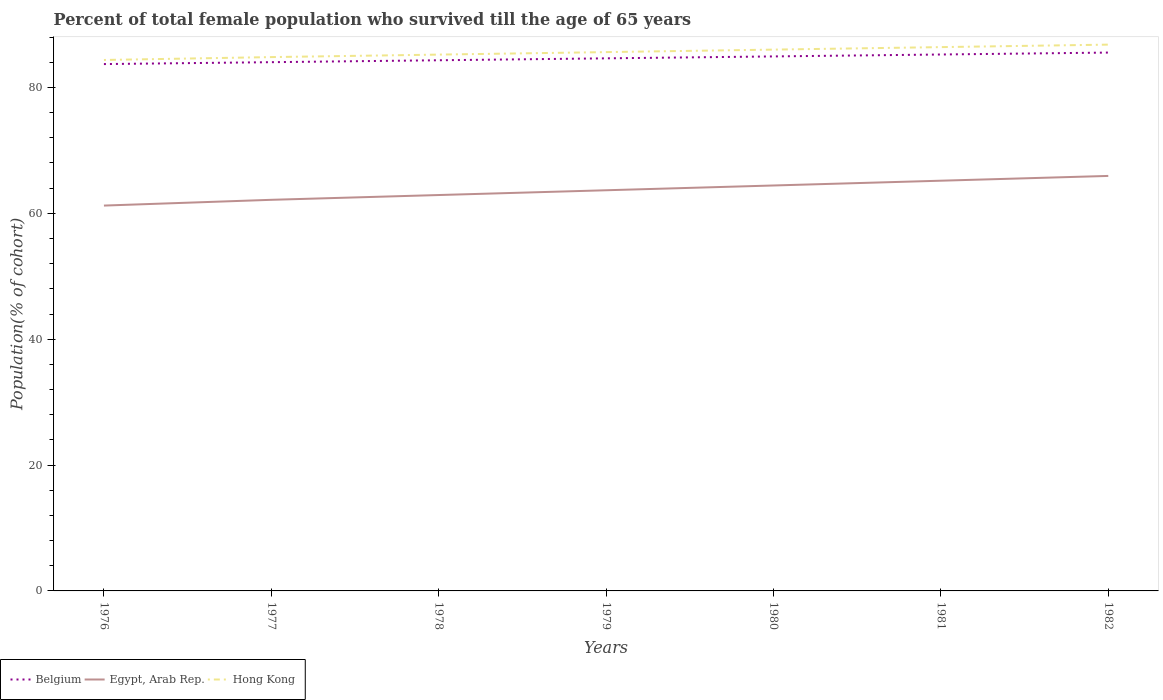Across all years, what is the maximum percentage of total female population who survived till the age of 65 years in Egypt, Arab Rep.?
Offer a very short reply. 61.23. In which year was the percentage of total female population who survived till the age of 65 years in Hong Kong maximum?
Provide a succinct answer. 1976. What is the total percentage of total female population who survived till the age of 65 years in Egypt, Arab Rep. in the graph?
Make the answer very short. -1.52. What is the difference between the highest and the second highest percentage of total female population who survived till the age of 65 years in Hong Kong?
Keep it short and to the point. 2.44. What is the difference between the highest and the lowest percentage of total female population who survived till the age of 65 years in Belgium?
Provide a short and direct response. 3. How many years are there in the graph?
Your answer should be very brief. 7. What is the difference between two consecutive major ticks on the Y-axis?
Provide a short and direct response. 20. Are the values on the major ticks of Y-axis written in scientific E-notation?
Your response must be concise. No. How are the legend labels stacked?
Ensure brevity in your answer.  Horizontal. What is the title of the graph?
Give a very brief answer. Percent of total female population who survived till the age of 65 years. Does "China" appear as one of the legend labels in the graph?
Ensure brevity in your answer.  No. What is the label or title of the Y-axis?
Your answer should be very brief. Population(% of cohort). What is the Population(% of cohort) in Belgium in 1976?
Your answer should be compact. 83.72. What is the Population(% of cohort) of Egypt, Arab Rep. in 1976?
Make the answer very short. 61.23. What is the Population(% of cohort) of Hong Kong in 1976?
Offer a terse response. 84.37. What is the Population(% of cohort) in Belgium in 1977?
Keep it short and to the point. 84.02. What is the Population(% of cohort) in Egypt, Arab Rep. in 1977?
Your response must be concise. 62.15. What is the Population(% of cohort) in Hong Kong in 1977?
Keep it short and to the point. 84.82. What is the Population(% of cohort) of Belgium in 1978?
Your answer should be compact. 84.32. What is the Population(% of cohort) of Egypt, Arab Rep. in 1978?
Your answer should be very brief. 62.91. What is the Population(% of cohort) of Hong Kong in 1978?
Your answer should be compact. 85.22. What is the Population(% of cohort) of Belgium in 1979?
Provide a short and direct response. 84.63. What is the Population(% of cohort) in Egypt, Arab Rep. in 1979?
Provide a short and direct response. 63.67. What is the Population(% of cohort) in Hong Kong in 1979?
Keep it short and to the point. 85.62. What is the Population(% of cohort) in Belgium in 1980?
Provide a succinct answer. 84.93. What is the Population(% of cohort) in Egypt, Arab Rep. in 1980?
Your answer should be very brief. 64.42. What is the Population(% of cohort) of Hong Kong in 1980?
Your answer should be compact. 86.01. What is the Population(% of cohort) in Belgium in 1981?
Give a very brief answer. 85.24. What is the Population(% of cohort) of Egypt, Arab Rep. in 1981?
Provide a short and direct response. 65.18. What is the Population(% of cohort) in Hong Kong in 1981?
Your answer should be very brief. 86.41. What is the Population(% of cohort) of Belgium in 1982?
Make the answer very short. 85.54. What is the Population(% of cohort) in Egypt, Arab Rep. in 1982?
Ensure brevity in your answer.  65.94. What is the Population(% of cohort) in Hong Kong in 1982?
Keep it short and to the point. 86.81. Across all years, what is the maximum Population(% of cohort) in Belgium?
Offer a very short reply. 85.54. Across all years, what is the maximum Population(% of cohort) of Egypt, Arab Rep.?
Your answer should be very brief. 65.94. Across all years, what is the maximum Population(% of cohort) in Hong Kong?
Provide a short and direct response. 86.81. Across all years, what is the minimum Population(% of cohort) of Belgium?
Ensure brevity in your answer.  83.72. Across all years, what is the minimum Population(% of cohort) in Egypt, Arab Rep.?
Provide a succinct answer. 61.23. Across all years, what is the minimum Population(% of cohort) in Hong Kong?
Offer a terse response. 84.37. What is the total Population(% of cohort) in Belgium in the graph?
Provide a succinct answer. 592.4. What is the total Population(% of cohort) in Egypt, Arab Rep. in the graph?
Ensure brevity in your answer.  445.5. What is the total Population(% of cohort) of Hong Kong in the graph?
Provide a short and direct response. 599.26. What is the difference between the Population(% of cohort) in Belgium in 1976 and that in 1977?
Ensure brevity in your answer.  -0.3. What is the difference between the Population(% of cohort) in Egypt, Arab Rep. in 1976 and that in 1977?
Give a very brief answer. -0.92. What is the difference between the Population(% of cohort) of Hong Kong in 1976 and that in 1977?
Your answer should be compact. -0.46. What is the difference between the Population(% of cohort) in Belgium in 1976 and that in 1978?
Provide a succinct answer. -0.61. What is the difference between the Population(% of cohort) of Egypt, Arab Rep. in 1976 and that in 1978?
Your answer should be compact. -1.67. What is the difference between the Population(% of cohort) of Hong Kong in 1976 and that in 1978?
Your response must be concise. -0.85. What is the difference between the Population(% of cohort) of Belgium in 1976 and that in 1979?
Offer a very short reply. -0.91. What is the difference between the Population(% of cohort) of Egypt, Arab Rep. in 1976 and that in 1979?
Offer a very short reply. -2.43. What is the difference between the Population(% of cohort) of Hong Kong in 1976 and that in 1979?
Your answer should be very brief. -1.25. What is the difference between the Population(% of cohort) of Belgium in 1976 and that in 1980?
Offer a terse response. -1.22. What is the difference between the Population(% of cohort) of Egypt, Arab Rep. in 1976 and that in 1980?
Keep it short and to the point. -3.19. What is the difference between the Population(% of cohort) of Hong Kong in 1976 and that in 1980?
Offer a terse response. -1.65. What is the difference between the Population(% of cohort) of Belgium in 1976 and that in 1981?
Offer a terse response. -1.52. What is the difference between the Population(% of cohort) in Egypt, Arab Rep. in 1976 and that in 1981?
Keep it short and to the point. -3.95. What is the difference between the Population(% of cohort) in Hong Kong in 1976 and that in 1981?
Give a very brief answer. -2.04. What is the difference between the Population(% of cohort) of Belgium in 1976 and that in 1982?
Give a very brief answer. -1.83. What is the difference between the Population(% of cohort) of Egypt, Arab Rep. in 1976 and that in 1982?
Give a very brief answer. -4.71. What is the difference between the Population(% of cohort) in Hong Kong in 1976 and that in 1982?
Your answer should be compact. -2.44. What is the difference between the Population(% of cohort) of Belgium in 1977 and that in 1978?
Provide a short and direct response. -0.31. What is the difference between the Population(% of cohort) in Egypt, Arab Rep. in 1977 and that in 1978?
Provide a short and direct response. -0.76. What is the difference between the Population(% of cohort) of Hong Kong in 1977 and that in 1978?
Your answer should be very brief. -0.4. What is the difference between the Population(% of cohort) in Belgium in 1977 and that in 1979?
Ensure brevity in your answer.  -0.61. What is the difference between the Population(% of cohort) in Egypt, Arab Rep. in 1977 and that in 1979?
Make the answer very short. -1.52. What is the difference between the Population(% of cohort) in Hong Kong in 1977 and that in 1979?
Offer a very short reply. -0.79. What is the difference between the Population(% of cohort) of Belgium in 1977 and that in 1980?
Provide a short and direct response. -0.92. What is the difference between the Population(% of cohort) in Egypt, Arab Rep. in 1977 and that in 1980?
Offer a very short reply. -2.28. What is the difference between the Population(% of cohort) in Hong Kong in 1977 and that in 1980?
Your answer should be very brief. -1.19. What is the difference between the Population(% of cohort) of Belgium in 1977 and that in 1981?
Ensure brevity in your answer.  -1.22. What is the difference between the Population(% of cohort) in Egypt, Arab Rep. in 1977 and that in 1981?
Provide a succinct answer. -3.04. What is the difference between the Population(% of cohort) of Hong Kong in 1977 and that in 1981?
Offer a terse response. -1.59. What is the difference between the Population(% of cohort) in Belgium in 1977 and that in 1982?
Offer a very short reply. -1.53. What is the difference between the Population(% of cohort) of Egypt, Arab Rep. in 1977 and that in 1982?
Keep it short and to the point. -3.8. What is the difference between the Population(% of cohort) in Hong Kong in 1977 and that in 1982?
Ensure brevity in your answer.  -1.98. What is the difference between the Population(% of cohort) in Belgium in 1978 and that in 1979?
Provide a succinct answer. -0.31. What is the difference between the Population(% of cohort) of Egypt, Arab Rep. in 1978 and that in 1979?
Provide a succinct answer. -0.76. What is the difference between the Population(% of cohort) in Hong Kong in 1978 and that in 1979?
Provide a succinct answer. -0.4. What is the difference between the Population(% of cohort) of Belgium in 1978 and that in 1980?
Keep it short and to the point. -0.61. What is the difference between the Population(% of cohort) of Egypt, Arab Rep. in 1978 and that in 1980?
Provide a short and direct response. -1.52. What is the difference between the Population(% of cohort) in Hong Kong in 1978 and that in 1980?
Provide a short and direct response. -0.79. What is the difference between the Population(% of cohort) of Belgium in 1978 and that in 1981?
Your answer should be very brief. -0.92. What is the difference between the Population(% of cohort) in Egypt, Arab Rep. in 1978 and that in 1981?
Offer a terse response. -2.28. What is the difference between the Population(% of cohort) of Hong Kong in 1978 and that in 1981?
Offer a very short reply. -1.19. What is the difference between the Population(% of cohort) in Belgium in 1978 and that in 1982?
Provide a succinct answer. -1.22. What is the difference between the Population(% of cohort) of Egypt, Arab Rep. in 1978 and that in 1982?
Make the answer very short. -3.04. What is the difference between the Population(% of cohort) of Hong Kong in 1978 and that in 1982?
Make the answer very short. -1.59. What is the difference between the Population(% of cohort) in Belgium in 1979 and that in 1980?
Provide a succinct answer. -0.31. What is the difference between the Population(% of cohort) in Egypt, Arab Rep. in 1979 and that in 1980?
Provide a short and direct response. -0.76. What is the difference between the Population(% of cohort) of Hong Kong in 1979 and that in 1980?
Your response must be concise. -0.4. What is the difference between the Population(% of cohort) in Belgium in 1979 and that in 1981?
Keep it short and to the point. -0.61. What is the difference between the Population(% of cohort) in Egypt, Arab Rep. in 1979 and that in 1981?
Offer a terse response. -1.52. What is the difference between the Population(% of cohort) in Hong Kong in 1979 and that in 1981?
Provide a succinct answer. -0.79. What is the difference between the Population(% of cohort) in Belgium in 1979 and that in 1982?
Your answer should be very brief. -0.92. What is the difference between the Population(% of cohort) in Egypt, Arab Rep. in 1979 and that in 1982?
Provide a succinct answer. -2.28. What is the difference between the Population(% of cohort) of Hong Kong in 1979 and that in 1982?
Ensure brevity in your answer.  -1.19. What is the difference between the Population(% of cohort) of Belgium in 1980 and that in 1981?
Your response must be concise. -0.31. What is the difference between the Population(% of cohort) in Egypt, Arab Rep. in 1980 and that in 1981?
Provide a succinct answer. -0.76. What is the difference between the Population(% of cohort) in Hong Kong in 1980 and that in 1981?
Provide a short and direct response. -0.4. What is the difference between the Population(% of cohort) in Belgium in 1980 and that in 1982?
Provide a short and direct response. -0.61. What is the difference between the Population(% of cohort) of Egypt, Arab Rep. in 1980 and that in 1982?
Make the answer very short. -1.52. What is the difference between the Population(% of cohort) in Hong Kong in 1980 and that in 1982?
Offer a terse response. -0.79. What is the difference between the Population(% of cohort) of Belgium in 1981 and that in 1982?
Offer a terse response. -0.31. What is the difference between the Population(% of cohort) of Egypt, Arab Rep. in 1981 and that in 1982?
Your answer should be compact. -0.76. What is the difference between the Population(% of cohort) in Hong Kong in 1981 and that in 1982?
Your answer should be very brief. -0.4. What is the difference between the Population(% of cohort) in Belgium in 1976 and the Population(% of cohort) in Egypt, Arab Rep. in 1977?
Offer a very short reply. 21.57. What is the difference between the Population(% of cohort) in Belgium in 1976 and the Population(% of cohort) in Hong Kong in 1977?
Offer a terse response. -1.11. What is the difference between the Population(% of cohort) in Egypt, Arab Rep. in 1976 and the Population(% of cohort) in Hong Kong in 1977?
Ensure brevity in your answer.  -23.59. What is the difference between the Population(% of cohort) in Belgium in 1976 and the Population(% of cohort) in Egypt, Arab Rep. in 1978?
Provide a short and direct response. 20.81. What is the difference between the Population(% of cohort) of Belgium in 1976 and the Population(% of cohort) of Hong Kong in 1978?
Your answer should be very brief. -1.5. What is the difference between the Population(% of cohort) in Egypt, Arab Rep. in 1976 and the Population(% of cohort) in Hong Kong in 1978?
Provide a succinct answer. -23.99. What is the difference between the Population(% of cohort) in Belgium in 1976 and the Population(% of cohort) in Egypt, Arab Rep. in 1979?
Give a very brief answer. 20.05. What is the difference between the Population(% of cohort) in Belgium in 1976 and the Population(% of cohort) in Hong Kong in 1979?
Make the answer very short. -1.9. What is the difference between the Population(% of cohort) of Egypt, Arab Rep. in 1976 and the Population(% of cohort) of Hong Kong in 1979?
Offer a terse response. -24.39. What is the difference between the Population(% of cohort) of Belgium in 1976 and the Population(% of cohort) of Egypt, Arab Rep. in 1980?
Ensure brevity in your answer.  19.29. What is the difference between the Population(% of cohort) in Belgium in 1976 and the Population(% of cohort) in Hong Kong in 1980?
Ensure brevity in your answer.  -2.3. What is the difference between the Population(% of cohort) of Egypt, Arab Rep. in 1976 and the Population(% of cohort) of Hong Kong in 1980?
Your answer should be compact. -24.78. What is the difference between the Population(% of cohort) in Belgium in 1976 and the Population(% of cohort) in Egypt, Arab Rep. in 1981?
Make the answer very short. 18.53. What is the difference between the Population(% of cohort) of Belgium in 1976 and the Population(% of cohort) of Hong Kong in 1981?
Your response must be concise. -2.69. What is the difference between the Population(% of cohort) of Egypt, Arab Rep. in 1976 and the Population(% of cohort) of Hong Kong in 1981?
Your answer should be compact. -25.18. What is the difference between the Population(% of cohort) in Belgium in 1976 and the Population(% of cohort) in Egypt, Arab Rep. in 1982?
Ensure brevity in your answer.  17.77. What is the difference between the Population(% of cohort) in Belgium in 1976 and the Population(% of cohort) in Hong Kong in 1982?
Keep it short and to the point. -3.09. What is the difference between the Population(% of cohort) of Egypt, Arab Rep. in 1976 and the Population(% of cohort) of Hong Kong in 1982?
Give a very brief answer. -25.58. What is the difference between the Population(% of cohort) of Belgium in 1977 and the Population(% of cohort) of Egypt, Arab Rep. in 1978?
Provide a succinct answer. 21.11. What is the difference between the Population(% of cohort) of Belgium in 1977 and the Population(% of cohort) of Hong Kong in 1978?
Keep it short and to the point. -1.2. What is the difference between the Population(% of cohort) in Egypt, Arab Rep. in 1977 and the Population(% of cohort) in Hong Kong in 1978?
Provide a succinct answer. -23.07. What is the difference between the Population(% of cohort) in Belgium in 1977 and the Population(% of cohort) in Egypt, Arab Rep. in 1979?
Provide a short and direct response. 20.35. What is the difference between the Population(% of cohort) of Belgium in 1977 and the Population(% of cohort) of Hong Kong in 1979?
Offer a terse response. -1.6. What is the difference between the Population(% of cohort) in Egypt, Arab Rep. in 1977 and the Population(% of cohort) in Hong Kong in 1979?
Your answer should be very brief. -23.47. What is the difference between the Population(% of cohort) of Belgium in 1977 and the Population(% of cohort) of Egypt, Arab Rep. in 1980?
Ensure brevity in your answer.  19.59. What is the difference between the Population(% of cohort) of Belgium in 1977 and the Population(% of cohort) of Hong Kong in 1980?
Offer a terse response. -2. What is the difference between the Population(% of cohort) of Egypt, Arab Rep. in 1977 and the Population(% of cohort) of Hong Kong in 1980?
Provide a succinct answer. -23.87. What is the difference between the Population(% of cohort) of Belgium in 1977 and the Population(% of cohort) of Egypt, Arab Rep. in 1981?
Offer a terse response. 18.83. What is the difference between the Population(% of cohort) of Belgium in 1977 and the Population(% of cohort) of Hong Kong in 1981?
Give a very brief answer. -2.39. What is the difference between the Population(% of cohort) of Egypt, Arab Rep. in 1977 and the Population(% of cohort) of Hong Kong in 1981?
Offer a very short reply. -24.26. What is the difference between the Population(% of cohort) in Belgium in 1977 and the Population(% of cohort) in Egypt, Arab Rep. in 1982?
Offer a very short reply. 18.07. What is the difference between the Population(% of cohort) in Belgium in 1977 and the Population(% of cohort) in Hong Kong in 1982?
Make the answer very short. -2.79. What is the difference between the Population(% of cohort) in Egypt, Arab Rep. in 1977 and the Population(% of cohort) in Hong Kong in 1982?
Offer a very short reply. -24.66. What is the difference between the Population(% of cohort) of Belgium in 1978 and the Population(% of cohort) of Egypt, Arab Rep. in 1979?
Offer a terse response. 20.66. What is the difference between the Population(% of cohort) in Belgium in 1978 and the Population(% of cohort) in Hong Kong in 1979?
Provide a short and direct response. -1.3. What is the difference between the Population(% of cohort) in Egypt, Arab Rep. in 1978 and the Population(% of cohort) in Hong Kong in 1979?
Keep it short and to the point. -22.71. What is the difference between the Population(% of cohort) in Belgium in 1978 and the Population(% of cohort) in Egypt, Arab Rep. in 1980?
Offer a very short reply. 19.9. What is the difference between the Population(% of cohort) of Belgium in 1978 and the Population(% of cohort) of Hong Kong in 1980?
Provide a short and direct response. -1.69. What is the difference between the Population(% of cohort) in Egypt, Arab Rep. in 1978 and the Population(% of cohort) in Hong Kong in 1980?
Give a very brief answer. -23.11. What is the difference between the Population(% of cohort) of Belgium in 1978 and the Population(% of cohort) of Egypt, Arab Rep. in 1981?
Keep it short and to the point. 19.14. What is the difference between the Population(% of cohort) of Belgium in 1978 and the Population(% of cohort) of Hong Kong in 1981?
Your answer should be very brief. -2.09. What is the difference between the Population(% of cohort) of Egypt, Arab Rep. in 1978 and the Population(% of cohort) of Hong Kong in 1981?
Offer a terse response. -23.5. What is the difference between the Population(% of cohort) of Belgium in 1978 and the Population(% of cohort) of Egypt, Arab Rep. in 1982?
Offer a very short reply. 18.38. What is the difference between the Population(% of cohort) in Belgium in 1978 and the Population(% of cohort) in Hong Kong in 1982?
Offer a terse response. -2.48. What is the difference between the Population(% of cohort) of Egypt, Arab Rep. in 1978 and the Population(% of cohort) of Hong Kong in 1982?
Your answer should be very brief. -23.9. What is the difference between the Population(% of cohort) in Belgium in 1979 and the Population(% of cohort) in Egypt, Arab Rep. in 1980?
Your response must be concise. 20.2. What is the difference between the Population(% of cohort) of Belgium in 1979 and the Population(% of cohort) of Hong Kong in 1980?
Your response must be concise. -1.39. What is the difference between the Population(% of cohort) in Egypt, Arab Rep. in 1979 and the Population(% of cohort) in Hong Kong in 1980?
Offer a terse response. -22.35. What is the difference between the Population(% of cohort) of Belgium in 1979 and the Population(% of cohort) of Egypt, Arab Rep. in 1981?
Give a very brief answer. 19.44. What is the difference between the Population(% of cohort) of Belgium in 1979 and the Population(% of cohort) of Hong Kong in 1981?
Your answer should be very brief. -1.78. What is the difference between the Population(% of cohort) of Egypt, Arab Rep. in 1979 and the Population(% of cohort) of Hong Kong in 1981?
Your response must be concise. -22.74. What is the difference between the Population(% of cohort) of Belgium in 1979 and the Population(% of cohort) of Egypt, Arab Rep. in 1982?
Ensure brevity in your answer.  18.68. What is the difference between the Population(% of cohort) of Belgium in 1979 and the Population(% of cohort) of Hong Kong in 1982?
Provide a short and direct response. -2.18. What is the difference between the Population(% of cohort) in Egypt, Arab Rep. in 1979 and the Population(% of cohort) in Hong Kong in 1982?
Ensure brevity in your answer.  -23.14. What is the difference between the Population(% of cohort) in Belgium in 1980 and the Population(% of cohort) in Egypt, Arab Rep. in 1981?
Offer a very short reply. 19.75. What is the difference between the Population(% of cohort) of Belgium in 1980 and the Population(% of cohort) of Hong Kong in 1981?
Offer a very short reply. -1.48. What is the difference between the Population(% of cohort) of Egypt, Arab Rep. in 1980 and the Population(% of cohort) of Hong Kong in 1981?
Your response must be concise. -21.99. What is the difference between the Population(% of cohort) in Belgium in 1980 and the Population(% of cohort) in Egypt, Arab Rep. in 1982?
Offer a terse response. 18.99. What is the difference between the Population(% of cohort) in Belgium in 1980 and the Population(% of cohort) in Hong Kong in 1982?
Offer a terse response. -1.87. What is the difference between the Population(% of cohort) in Egypt, Arab Rep. in 1980 and the Population(% of cohort) in Hong Kong in 1982?
Provide a short and direct response. -22.38. What is the difference between the Population(% of cohort) in Belgium in 1981 and the Population(% of cohort) in Egypt, Arab Rep. in 1982?
Offer a very short reply. 19.29. What is the difference between the Population(% of cohort) in Belgium in 1981 and the Population(% of cohort) in Hong Kong in 1982?
Offer a terse response. -1.57. What is the difference between the Population(% of cohort) of Egypt, Arab Rep. in 1981 and the Population(% of cohort) of Hong Kong in 1982?
Your answer should be very brief. -21.62. What is the average Population(% of cohort) of Belgium per year?
Offer a very short reply. 84.63. What is the average Population(% of cohort) in Egypt, Arab Rep. per year?
Provide a short and direct response. 63.64. What is the average Population(% of cohort) in Hong Kong per year?
Your answer should be compact. 85.61. In the year 1976, what is the difference between the Population(% of cohort) of Belgium and Population(% of cohort) of Egypt, Arab Rep.?
Offer a very short reply. 22.48. In the year 1976, what is the difference between the Population(% of cohort) of Belgium and Population(% of cohort) of Hong Kong?
Give a very brief answer. -0.65. In the year 1976, what is the difference between the Population(% of cohort) in Egypt, Arab Rep. and Population(% of cohort) in Hong Kong?
Ensure brevity in your answer.  -23.14. In the year 1977, what is the difference between the Population(% of cohort) of Belgium and Population(% of cohort) of Egypt, Arab Rep.?
Provide a succinct answer. 21.87. In the year 1977, what is the difference between the Population(% of cohort) of Belgium and Population(% of cohort) of Hong Kong?
Offer a very short reply. -0.81. In the year 1977, what is the difference between the Population(% of cohort) in Egypt, Arab Rep. and Population(% of cohort) in Hong Kong?
Give a very brief answer. -22.68. In the year 1978, what is the difference between the Population(% of cohort) in Belgium and Population(% of cohort) in Egypt, Arab Rep.?
Offer a very short reply. 21.42. In the year 1978, what is the difference between the Population(% of cohort) of Belgium and Population(% of cohort) of Hong Kong?
Your answer should be very brief. -0.9. In the year 1978, what is the difference between the Population(% of cohort) in Egypt, Arab Rep. and Population(% of cohort) in Hong Kong?
Offer a terse response. -22.31. In the year 1979, what is the difference between the Population(% of cohort) of Belgium and Population(% of cohort) of Egypt, Arab Rep.?
Give a very brief answer. 20.96. In the year 1979, what is the difference between the Population(% of cohort) of Belgium and Population(% of cohort) of Hong Kong?
Your answer should be very brief. -0.99. In the year 1979, what is the difference between the Population(% of cohort) in Egypt, Arab Rep. and Population(% of cohort) in Hong Kong?
Make the answer very short. -21.95. In the year 1980, what is the difference between the Population(% of cohort) of Belgium and Population(% of cohort) of Egypt, Arab Rep.?
Offer a very short reply. 20.51. In the year 1980, what is the difference between the Population(% of cohort) in Belgium and Population(% of cohort) in Hong Kong?
Provide a short and direct response. -1.08. In the year 1980, what is the difference between the Population(% of cohort) in Egypt, Arab Rep. and Population(% of cohort) in Hong Kong?
Provide a succinct answer. -21.59. In the year 1981, what is the difference between the Population(% of cohort) in Belgium and Population(% of cohort) in Egypt, Arab Rep.?
Ensure brevity in your answer.  20.05. In the year 1981, what is the difference between the Population(% of cohort) of Belgium and Population(% of cohort) of Hong Kong?
Give a very brief answer. -1.17. In the year 1981, what is the difference between the Population(% of cohort) of Egypt, Arab Rep. and Population(% of cohort) of Hong Kong?
Keep it short and to the point. -21.23. In the year 1982, what is the difference between the Population(% of cohort) of Belgium and Population(% of cohort) of Egypt, Arab Rep.?
Your response must be concise. 19.6. In the year 1982, what is the difference between the Population(% of cohort) of Belgium and Population(% of cohort) of Hong Kong?
Provide a short and direct response. -1.26. In the year 1982, what is the difference between the Population(% of cohort) of Egypt, Arab Rep. and Population(% of cohort) of Hong Kong?
Keep it short and to the point. -20.86. What is the ratio of the Population(% of cohort) in Belgium in 1976 to that in 1977?
Your answer should be compact. 1. What is the ratio of the Population(% of cohort) in Hong Kong in 1976 to that in 1977?
Offer a terse response. 0.99. What is the ratio of the Population(% of cohort) in Belgium in 1976 to that in 1978?
Provide a succinct answer. 0.99. What is the ratio of the Population(% of cohort) in Egypt, Arab Rep. in 1976 to that in 1978?
Your response must be concise. 0.97. What is the ratio of the Population(% of cohort) in Hong Kong in 1976 to that in 1978?
Ensure brevity in your answer.  0.99. What is the ratio of the Population(% of cohort) of Belgium in 1976 to that in 1979?
Your answer should be very brief. 0.99. What is the ratio of the Population(% of cohort) of Egypt, Arab Rep. in 1976 to that in 1979?
Your answer should be compact. 0.96. What is the ratio of the Population(% of cohort) in Hong Kong in 1976 to that in 1979?
Give a very brief answer. 0.99. What is the ratio of the Population(% of cohort) of Belgium in 1976 to that in 1980?
Your response must be concise. 0.99. What is the ratio of the Population(% of cohort) of Egypt, Arab Rep. in 1976 to that in 1980?
Offer a terse response. 0.95. What is the ratio of the Population(% of cohort) of Hong Kong in 1976 to that in 1980?
Your answer should be very brief. 0.98. What is the ratio of the Population(% of cohort) of Belgium in 1976 to that in 1981?
Make the answer very short. 0.98. What is the ratio of the Population(% of cohort) in Egypt, Arab Rep. in 1976 to that in 1981?
Give a very brief answer. 0.94. What is the ratio of the Population(% of cohort) of Hong Kong in 1976 to that in 1981?
Offer a very short reply. 0.98. What is the ratio of the Population(% of cohort) in Belgium in 1976 to that in 1982?
Give a very brief answer. 0.98. What is the ratio of the Population(% of cohort) in Egypt, Arab Rep. in 1976 to that in 1982?
Keep it short and to the point. 0.93. What is the ratio of the Population(% of cohort) in Hong Kong in 1976 to that in 1982?
Keep it short and to the point. 0.97. What is the ratio of the Population(% of cohort) of Belgium in 1977 to that in 1978?
Your answer should be very brief. 1. What is the ratio of the Population(% of cohort) of Egypt, Arab Rep. in 1977 to that in 1978?
Your response must be concise. 0.99. What is the ratio of the Population(% of cohort) in Hong Kong in 1977 to that in 1978?
Ensure brevity in your answer.  1. What is the ratio of the Population(% of cohort) in Egypt, Arab Rep. in 1977 to that in 1979?
Make the answer very short. 0.98. What is the ratio of the Population(% of cohort) in Hong Kong in 1977 to that in 1979?
Provide a short and direct response. 0.99. What is the ratio of the Population(% of cohort) in Egypt, Arab Rep. in 1977 to that in 1980?
Offer a terse response. 0.96. What is the ratio of the Population(% of cohort) of Hong Kong in 1977 to that in 1980?
Give a very brief answer. 0.99. What is the ratio of the Population(% of cohort) in Belgium in 1977 to that in 1981?
Provide a short and direct response. 0.99. What is the ratio of the Population(% of cohort) in Egypt, Arab Rep. in 1977 to that in 1981?
Keep it short and to the point. 0.95. What is the ratio of the Population(% of cohort) of Hong Kong in 1977 to that in 1981?
Ensure brevity in your answer.  0.98. What is the ratio of the Population(% of cohort) in Belgium in 1977 to that in 1982?
Ensure brevity in your answer.  0.98. What is the ratio of the Population(% of cohort) in Egypt, Arab Rep. in 1977 to that in 1982?
Offer a terse response. 0.94. What is the ratio of the Population(% of cohort) of Hong Kong in 1977 to that in 1982?
Give a very brief answer. 0.98. What is the ratio of the Population(% of cohort) in Egypt, Arab Rep. in 1978 to that in 1980?
Provide a succinct answer. 0.98. What is the ratio of the Population(% of cohort) of Hong Kong in 1978 to that in 1980?
Your answer should be compact. 0.99. What is the ratio of the Population(% of cohort) of Belgium in 1978 to that in 1981?
Keep it short and to the point. 0.99. What is the ratio of the Population(% of cohort) of Egypt, Arab Rep. in 1978 to that in 1981?
Keep it short and to the point. 0.97. What is the ratio of the Population(% of cohort) of Hong Kong in 1978 to that in 1981?
Offer a very short reply. 0.99. What is the ratio of the Population(% of cohort) in Belgium in 1978 to that in 1982?
Provide a succinct answer. 0.99. What is the ratio of the Population(% of cohort) of Egypt, Arab Rep. in 1978 to that in 1982?
Provide a short and direct response. 0.95. What is the ratio of the Population(% of cohort) in Hong Kong in 1978 to that in 1982?
Make the answer very short. 0.98. What is the ratio of the Population(% of cohort) in Hong Kong in 1979 to that in 1980?
Keep it short and to the point. 1. What is the ratio of the Population(% of cohort) in Belgium in 1979 to that in 1981?
Ensure brevity in your answer.  0.99. What is the ratio of the Population(% of cohort) in Egypt, Arab Rep. in 1979 to that in 1981?
Your answer should be compact. 0.98. What is the ratio of the Population(% of cohort) of Belgium in 1979 to that in 1982?
Your answer should be compact. 0.99. What is the ratio of the Population(% of cohort) of Egypt, Arab Rep. in 1979 to that in 1982?
Provide a short and direct response. 0.97. What is the ratio of the Population(% of cohort) of Hong Kong in 1979 to that in 1982?
Provide a succinct answer. 0.99. What is the ratio of the Population(% of cohort) of Belgium in 1980 to that in 1981?
Your answer should be compact. 1. What is the ratio of the Population(% of cohort) in Egypt, Arab Rep. in 1980 to that in 1981?
Provide a short and direct response. 0.99. What is the ratio of the Population(% of cohort) in Hong Kong in 1980 to that in 1982?
Make the answer very short. 0.99. What is the difference between the highest and the second highest Population(% of cohort) of Belgium?
Offer a terse response. 0.31. What is the difference between the highest and the second highest Population(% of cohort) of Egypt, Arab Rep.?
Your answer should be compact. 0.76. What is the difference between the highest and the second highest Population(% of cohort) of Hong Kong?
Your answer should be compact. 0.4. What is the difference between the highest and the lowest Population(% of cohort) of Belgium?
Make the answer very short. 1.83. What is the difference between the highest and the lowest Population(% of cohort) in Egypt, Arab Rep.?
Your answer should be compact. 4.71. What is the difference between the highest and the lowest Population(% of cohort) of Hong Kong?
Your answer should be compact. 2.44. 